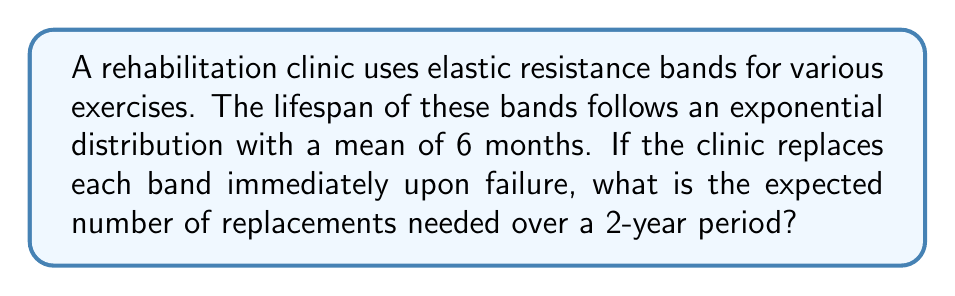Provide a solution to this math problem. To solve this problem, we'll use concepts from renewal theory and stochastic processes:

1) The exponential distribution with mean 6 months has a rate parameter $\lambda = \frac{1}{6}$ per month.

2) In renewal theory, the expected number of renewals (replacements) in time $t$ is given by the renewal function $m(t)$.

3) For an exponential distribution, the renewal function is:

   $$m(t) = \lambda t = \frac{t}{6}$$

4) The time period we're interested in is 2 years, which is 24 months.

5) Substituting into the renewal function:

   $$m(24) = \frac{24}{6} = 4$$

6) This means we expect 4 replacements over the 2-year period.

7) Note: This includes the initial band plus 3 replacements, or 4 bands total used over the period.
Answer: 4 replacements 